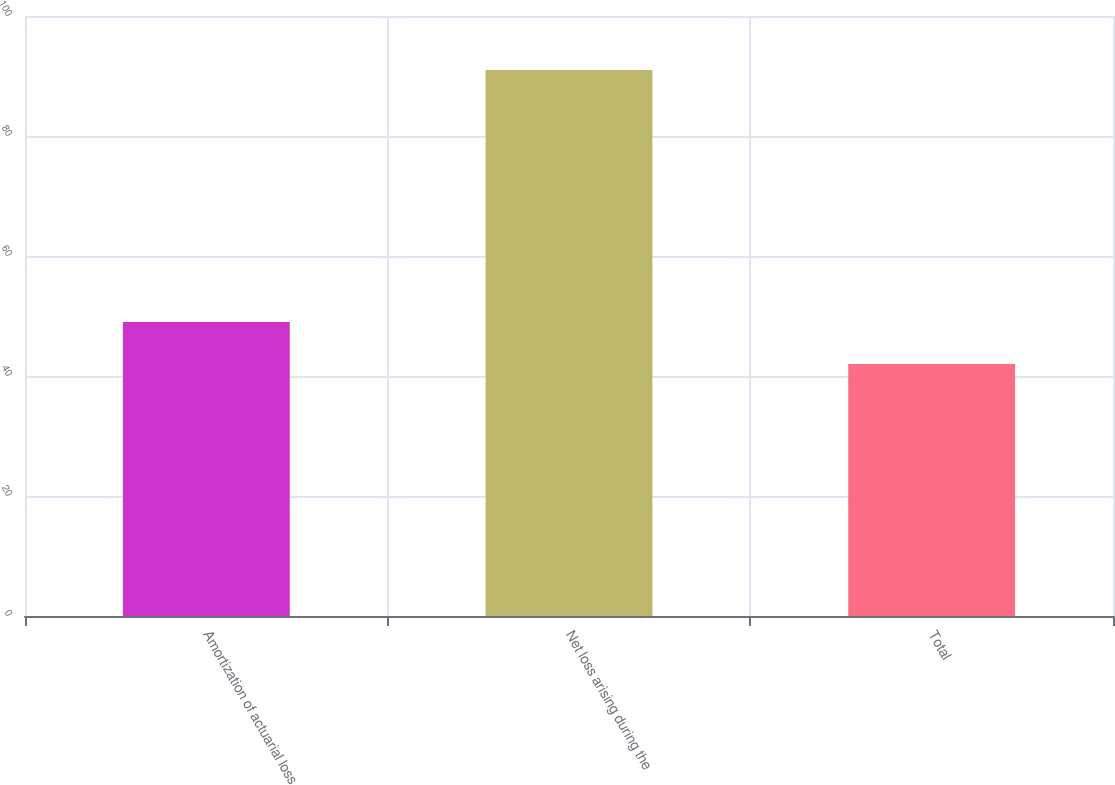<chart> <loc_0><loc_0><loc_500><loc_500><bar_chart><fcel>Amortization of actuarial loss<fcel>Net loss arising during the<fcel>Total<nl><fcel>49<fcel>91<fcel>42<nl></chart> 